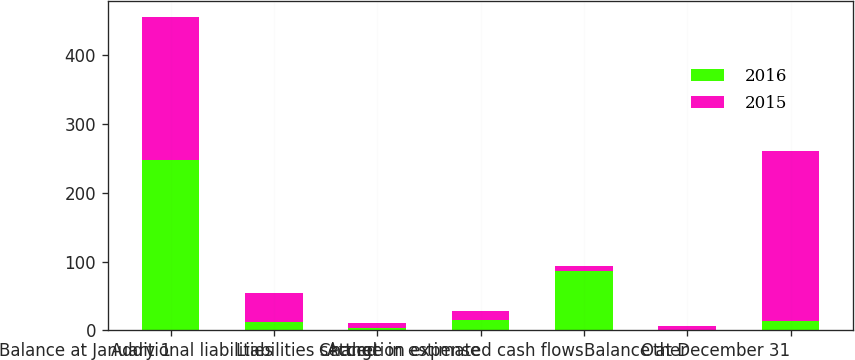Convert chart to OTSL. <chart><loc_0><loc_0><loc_500><loc_500><stacked_bar_chart><ecel><fcel>Balance at January 1<fcel>Additional liabilities<fcel>Liabilities settled<fcel>Accretion expense<fcel>Change in estimated cash flows<fcel>Other<fcel>Balance at December 31<nl><fcel>2016<fcel>247<fcel>12<fcel>4<fcel>15<fcel>86<fcel>1<fcel>13<nl><fcel>2015<fcel>209<fcel>43<fcel>6<fcel>13<fcel>7<fcel>5<fcel>247<nl></chart> 